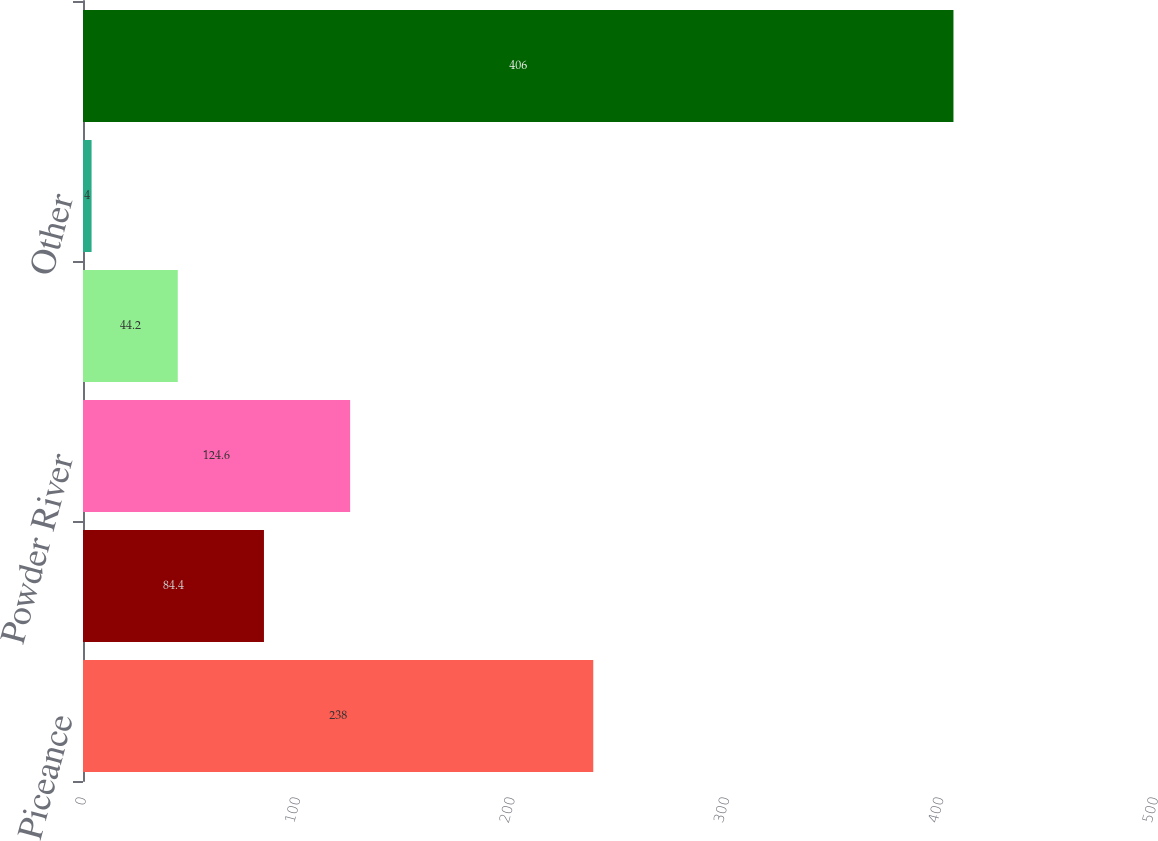Convert chart. <chart><loc_0><loc_0><loc_500><loc_500><bar_chart><fcel>Piceance<fcel>San Juan<fcel>Powder River<fcel>Mid-Continent<fcel>Other<fcel>Total<nl><fcel>238<fcel>84.4<fcel>124.6<fcel>44.2<fcel>4<fcel>406<nl></chart> 